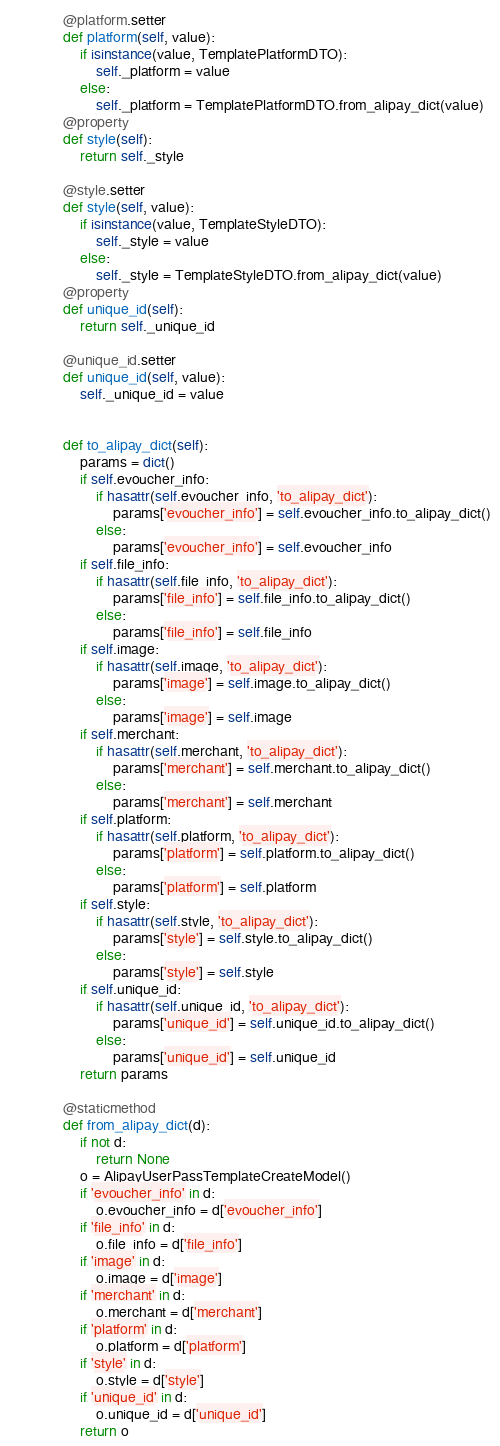Convert code to text. <code><loc_0><loc_0><loc_500><loc_500><_Python_>
    @platform.setter
    def platform(self, value):
        if isinstance(value, TemplatePlatformDTO):
            self._platform = value
        else:
            self._platform = TemplatePlatformDTO.from_alipay_dict(value)
    @property
    def style(self):
        return self._style

    @style.setter
    def style(self, value):
        if isinstance(value, TemplateStyleDTO):
            self._style = value
        else:
            self._style = TemplateStyleDTO.from_alipay_dict(value)
    @property
    def unique_id(self):
        return self._unique_id

    @unique_id.setter
    def unique_id(self, value):
        self._unique_id = value


    def to_alipay_dict(self):
        params = dict()
        if self.evoucher_info:
            if hasattr(self.evoucher_info, 'to_alipay_dict'):
                params['evoucher_info'] = self.evoucher_info.to_alipay_dict()
            else:
                params['evoucher_info'] = self.evoucher_info
        if self.file_info:
            if hasattr(self.file_info, 'to_alipay_dict'):
                params['file_info'] = self.file_info.to_alipay_dict()
            else:
                params['file_info'] = self.file_info
        if self.image:
            if hasattr(self.image, 'to_alipay_dict'):
                params['image'] = self.image.to_alipay_dict()
            else:
                params['image'] = self.image
        if self.merchant:
            if hasattr(self.merchant, 'to_alipay_dict'):
                params['merchant'] = self.merchant.to_alipay_dict()
            else:
                params['merchant'] = self.merchant
        if self.platform:
            if hasattr(self.platform, 'to_alipay_dict'):
                params['platform'] = self.platform.to_alipay_dict()
            else:
                params['platform'] = self.platform
        if self.style:
            if hasattr(self.style, 'to_alipay_dict'):
                params['style'] = self.style.to_alipay_dict()
            else:
                params['style'] = self.style
        if self.unique_id:
            if hasattr(self.unique_id, 'to_alipay_dict'):
                params['unique_id'] = self.unique_id.to_alipay_dict()
            else:
                params['unique_id'] = self.unique_id
        return params

    @staticmethod
    def from_alipay_dict(d):
        if not d:
            return None
        o = AlipayUserPassTemplateCreateModel()
        if 'evoucher_info' in d:
            o.evoucher_info = d['evoucher_info']
        if 'file_info' in d:
            o.file_info = d['file_info']
        if 'image' in d:
            o.image = d['image']
        if 'merchant' in d:
            o.merchant = d['merchant']
        if 'platform' in d:
            o.platform = d['platform']
        if 'style' in d:
            o.style = d['style']
        if 'unique_id' in d:
            o.unique_id = d['unique_id']
        return o


</code> 